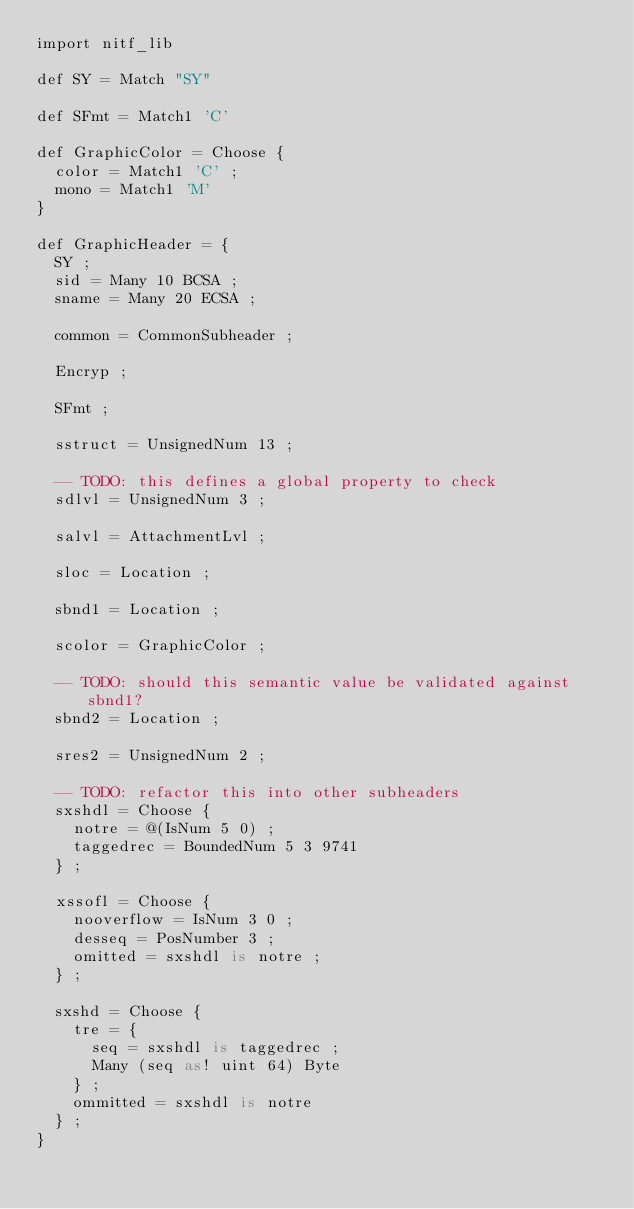<code> <loc_0><loc_0><loc_500><loc_500><_SQL_>import nitf_lib

def SY = Match "SY"

def SFmt = Match1 'C'

def GraphicColor = Choose {
  color = Match1 'C' ;
  mono = Match1 'M'
}

def GraphicHeader = {
  SY ;
  sid = Many 10 BCSA ;
  sname = Many 20 ECSA ;

  common = CommonSubheader ;

  Encryp ;

  SFmt ;

  sstruct = UnsignedNum 13 ;

  -- TODO: this defines a global property to check
  sdlvl = UnsignedNum 3 ;

  salvl = AttachmentLvl ;

  sloc = Location ;

  sbnd1 = Location ;

  scolor = GraphicColor ;

  -- TODO: should this semantic value be validated against sbnd1?
  sbnd2 = Location ;

  sres2 = UnsignedNum 2 ;

  -- TODO: refactor this into other subheaders
  sxshdl = Choose {
    notre = @(IsNum 5 0) ;
    taggedrec = BoundedNum 5 3 9741
  } ;

  xssofl = Choose {
    nooverflow = IsNum 3 0 ;
    desseq = PosNumber 3 ;
    omitted = sxshdl is notre ;
  } ;

  sxshd = Choose {
    tre = {
      seq = sxshdl is taggedrec ;
      Many (seq as! uint 64) Byte
    } ;
    ommitted = sxshdl is notre
  } ;
}
</code> 